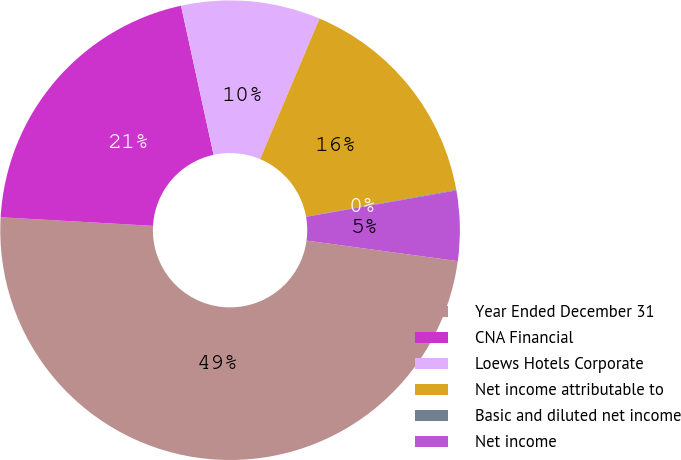Convert chart to OTSL. <chart><loc_0><loc_0><loc_500><loc_500><pie_chart><fcel>Year Ended December 31<fcel>CNA Financial<fcel>Loews Hotels Corporate<fcel>Net income attributable to<fcel>Basic and diluted net income<fcel>Net income<nl><fcel>48.75%<fcel>20.68%<fcel>9.79%<fcel>15.81%<fcel>0.05%<fcel>4.92%<nl></chart> 